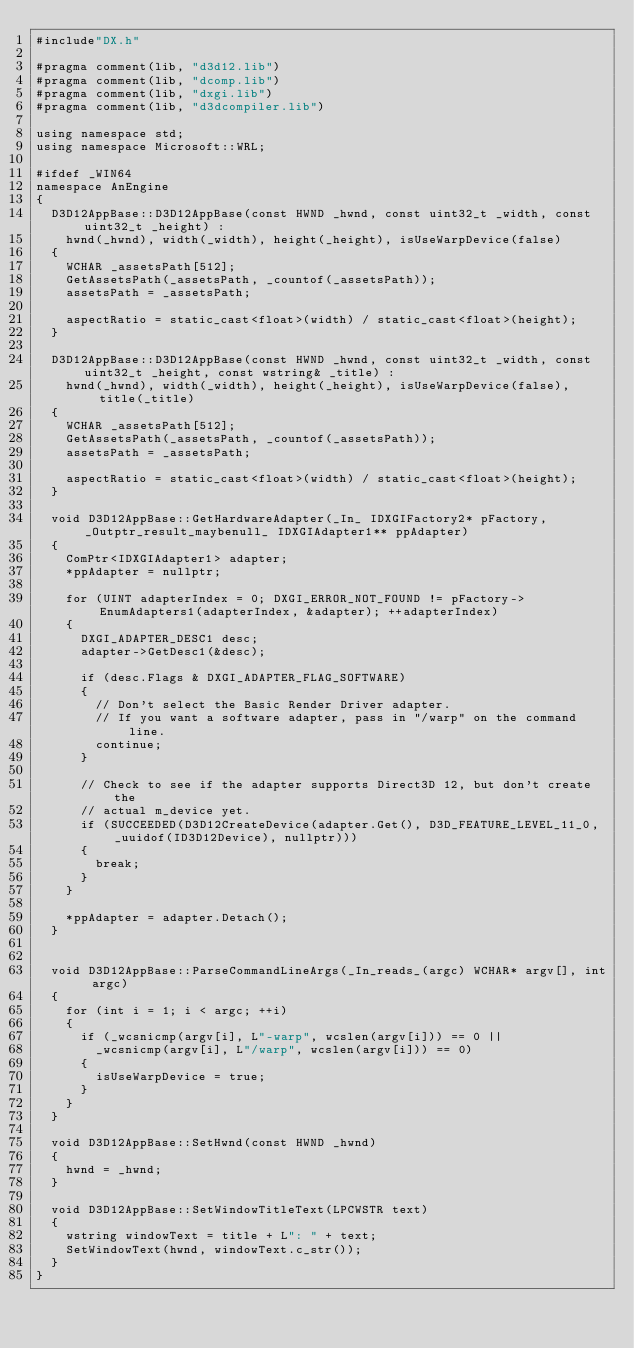<code> <loc_0><loc_0><loc_500><loc_500><_C++_>#include"DX.h"

#pragma comment(lib, "d3d12.lib")
#pragma comment(lib, "dcomp.lib")
#pragma comment(lib, "dxgi.lib")
#pragma comment(lib, "d3dcompiler.lib")

using namespace std;
using namespace Microsoft::WRL;

#ifdef _WIN64
namespace AnEngine
{
	D3D12AppBase::D3D12AppBase(const HWND _hwnd, const uint32_t _width, const uint32_t _height) :
		hwnd(_hwnd), width(_width), height(_height), isUseWarpDevice(false)
	{
		WCHAR _assetsPath[512];
		GetAssetsPath(_assetsPath, _countof(_assetsPath));
		assetsPath = _assetsPath;

		aspectRatio = static_cast<float>(width) / static_cast<float>(height);
	}

	D3D12AppBase::D3D12AppBase(const HWND _hwnd, const uint32_t _width, const uint32_t _height, const wstring& _title) :
		hwnd(_hwnd), width(_width), height(_height), isUseWarpDevice(false), title(_title)
	{
		WCHAR _assetsPath[512];
		GetAssetsPath(_assetsPath, _countof(_assetsPath));
		assetsPath = _assetsPath;

		aspectRatio = static_cast<float>(width) / static_cast<float>(height);
	}

	void D3D12AppBase::GetHardwareAdapter(_In_ IDXGIFactory2* pFactory, _Outptr_result_maybenull_ IDXGIAdapter1** ppAdapter)
	{
		ComPtr<IDXGIAdapter1> adapter;
		*ppAdapter = nullptr;

		for (UINT adapterIndex = 0; DXGI_ERROR_NOT_FOUND != pFactory->EnumAdapters1(adapterIndex, &adapter); ++adapterIndex)
		{
			DXGI_ADAPTER_DESC1 desc;
			adapter->GetDesc1(&desc);

			if (desc.Flags & DXGI_ADAPTER_FLAG_SOFTWARE)
			{
				// Don't select the Basic Render Driver adapter.
				// If you want a software adapter, pass in "/warp" on the command line.
				continue;
			}

			// Check to see if the adapter supports Direct3D 12, but don't create the
			// actual m_device yet.
			if (SUCCEEDED(D3D12CreateDevice(adapter.Get(), D3D_FEATURE_LEVEL_11_0, _uuidof(ID3D12Device), nullptr)))
			{
				break;
			}
		}

		*ppAdapter = adapter.Detach();
	}


	void D3D12AppBase::ParseCommandLineArgs(_In_reads_(argc) WCHAR* argv[], int argc)
	{
		for (int i = 1; i < argc; ++i)
		{
			if (_wcsnicmp(argv[i], L"-warp", wcslen(argv[i])) == 0 ||
				_wcsnicmp(argv[i], L"/warp", wcslen(argv[i])) == 0)
			{
				isUseWarpDevice = true;
			}
		}
	}

	void D3D12AppBase::SetHwnd(const HWND _hwnd)
	{
		hwnd = _hwnd;
	}

	void D3D12AppBase::SetWindowTitleText(LPCWSTR text)
	{
		wstring windowText = title + L": " + text;
		SetWindowText(hwnd, windowText.c_str());
	}
}</code> 